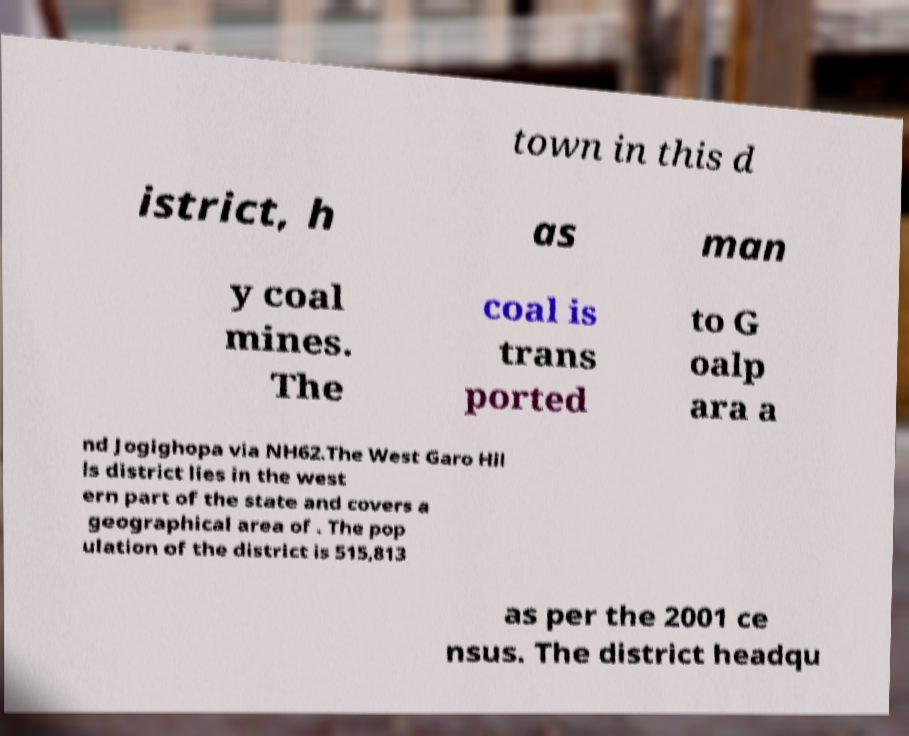I need the written content from this picture converted into text. Can you do that? town in this d istrict, h as man y coal mines. The coal is trans ported to G oalp ara a nd Jogighopa via NH62.The West Garo Hil ls district lies in the west ern part of the state and covers a geographical area of . The pop ulation of the district is 515,813 as per the 2001 ce nsus. The district headqu 